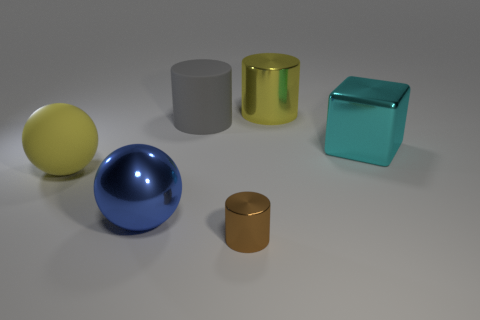Add 4 shiny things. How many objects exist? 10 Subtract all blocks. How many objects are left? 5 Add 3 purple objects. How many purple objects exist? 3 Subtract 1 cyan cubes. How many objects are left? 5 Subtract all cyan balls. Subtract all big gray cylinders. How many objects are left? 5 Add 6 small metal cylinders. How many small metal cylinders are left? 7 